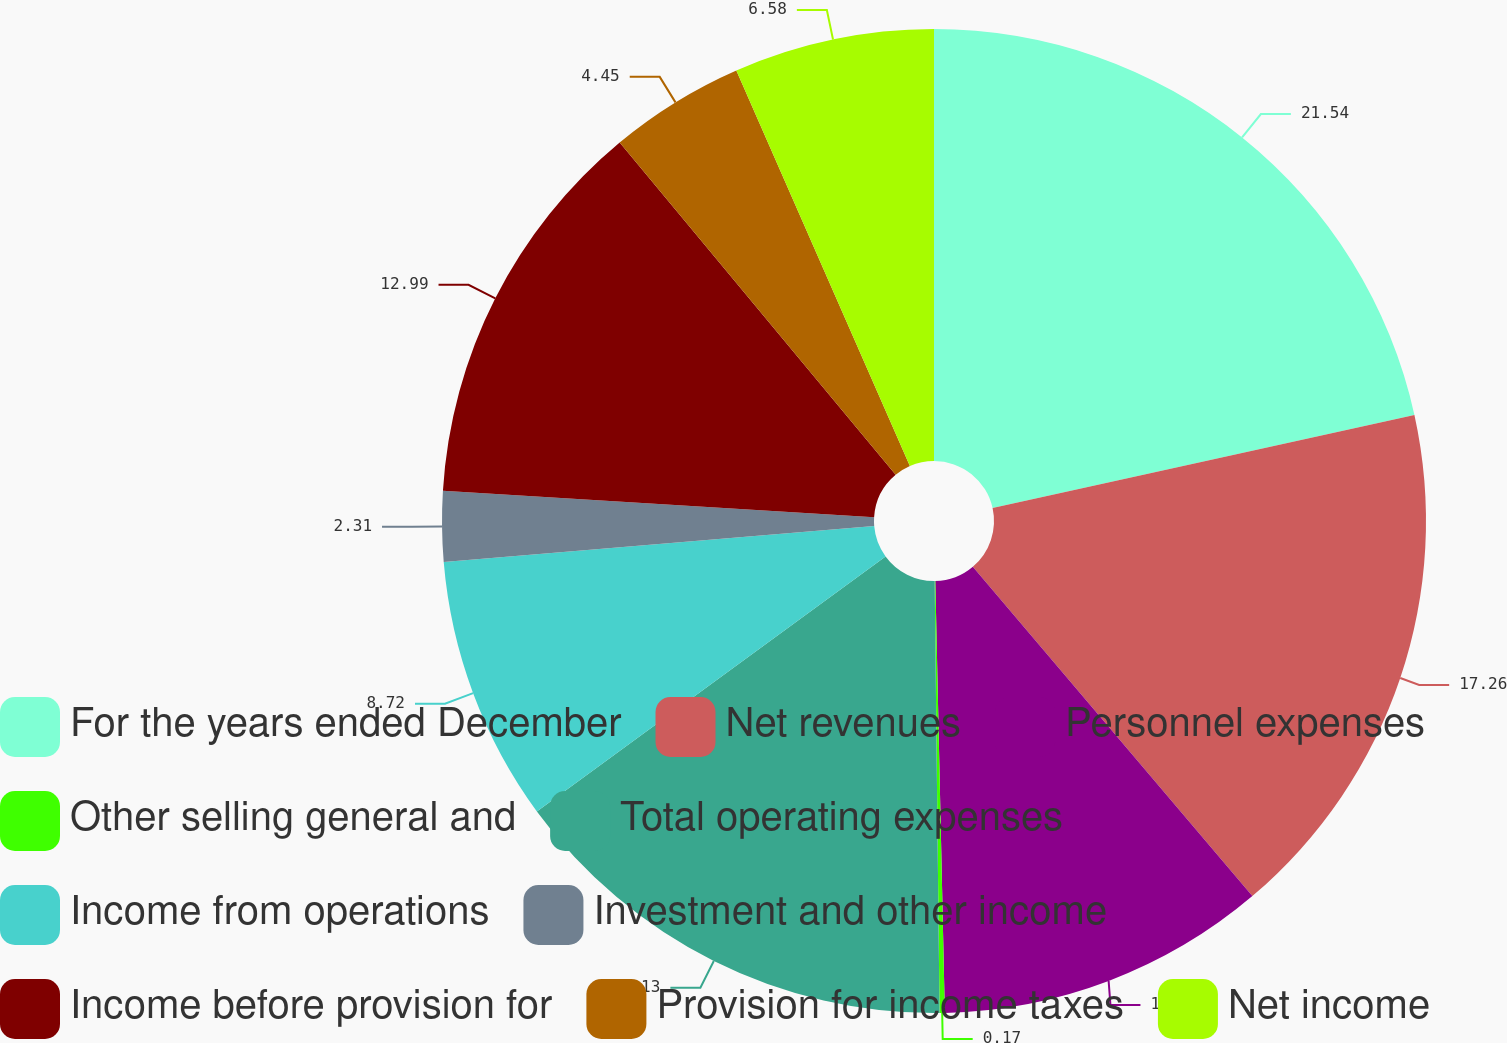<chart> <loc_0><loc_0><loc_500><loc_500><pie_chart><fcel>For the years ended December<fcel>Net revenues<fcel>Personnel expenses<fcel>Other selling general and<fcel>Total operating expenses<fcel>Income from operations<fcel>Investment and other income<fcel>Income before provision for<fcel>Provision for income taxes<fcel>Net income<nl><fcel>21.54%<fcel>17.26%<fcel>10.85%<fcel>0.17%<fcel>15.13%<fcel>8.72%<fcel>2.31%<fcel>12.99%<fcel>4.45%<fcel>6.58%<nl></chart> 